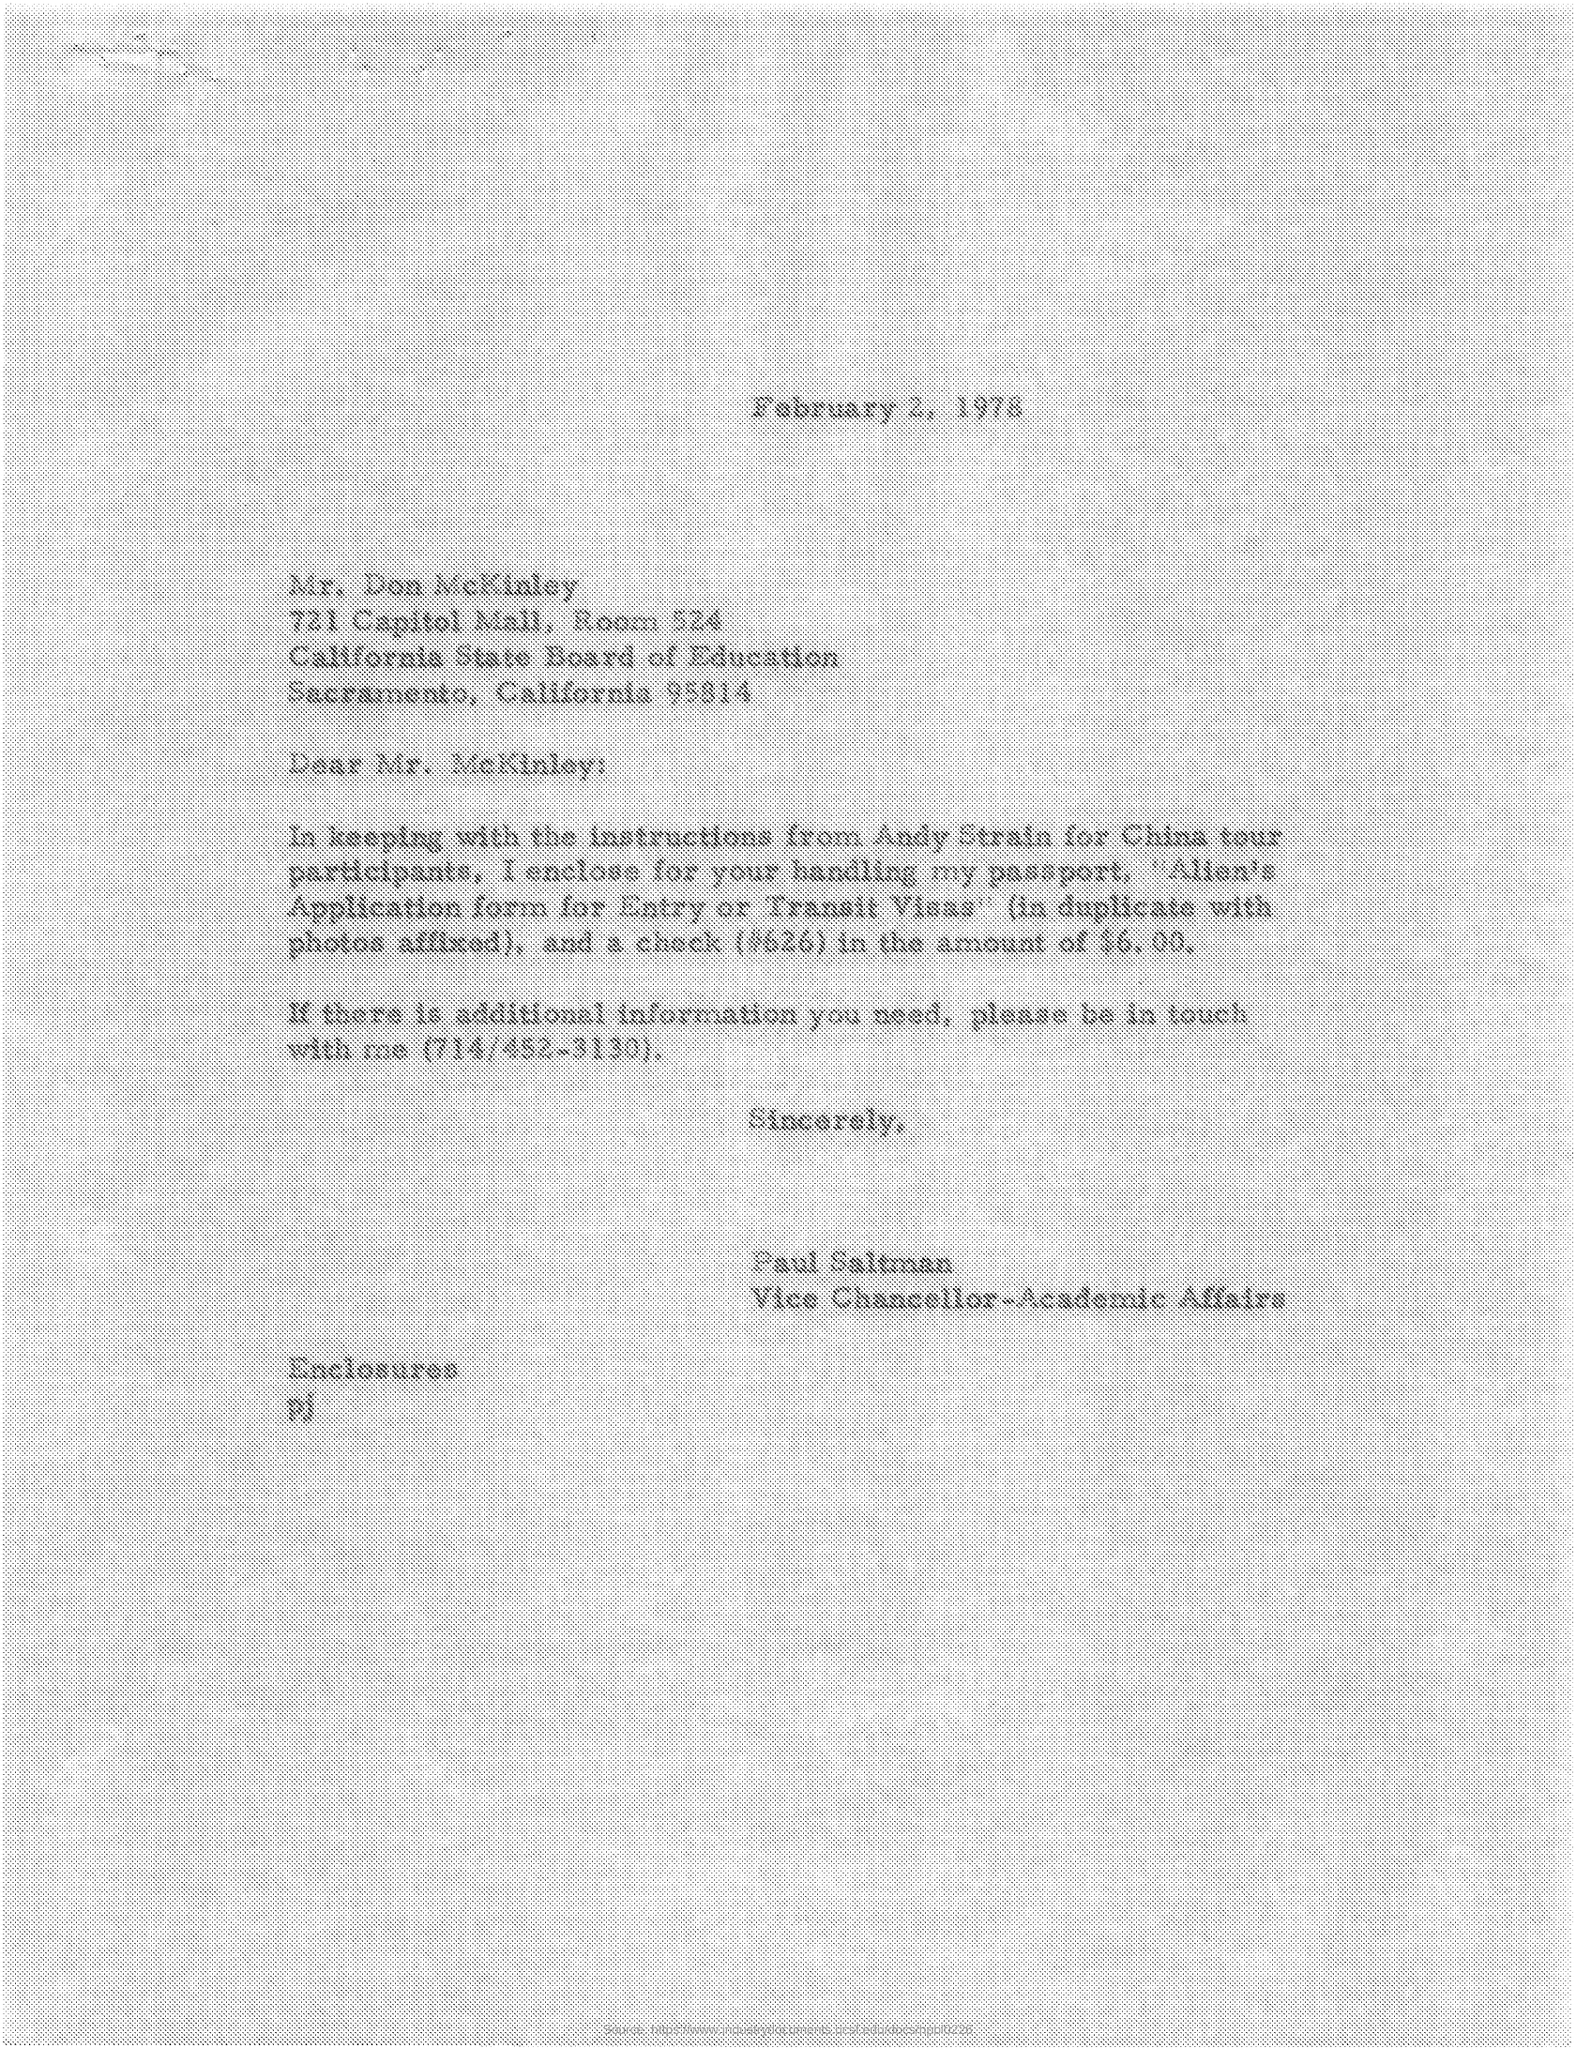Mention a couple of crucial points in this snapshot. The issued date of this letter is February 2, 1978. Paul Saltman holds the designation of Vice Chancellor-Academic Affairs. The sender of this letter is Paul Saltman. 